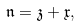Convert formula to latex. <formula><loc_0><loc_0><loc_500><loc_500>\mathfrak n = \mathfrak z + \mathfrak x ,</formula> 